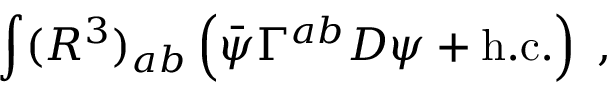Convert formula to latex. <formula><loc_0><loc_0><loc_500><loc_500>\int ( R ^ { 3 } ) _ { a b } \left ( \bar { \psi } \Gamma ^ { a b } D \psi + h . c . \right ) \, ,</formula> 